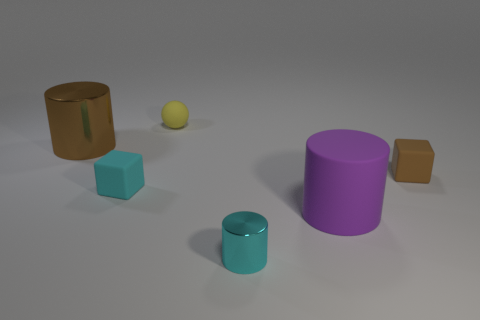Add 2 tiny yellow balls. How many objects exist? 8 Subtract all blocks. How many objects are left? 4 Add 2 small cyan rubber things. How many small cyan rubber things exist? 3 Subtract 0 blue balls. How many objects are left? 6 Subtract all tiny red matte spheres. Subtract all brown things. How many objects are left? 4 Add 6 cylinders. How many cylinders are left? 9 